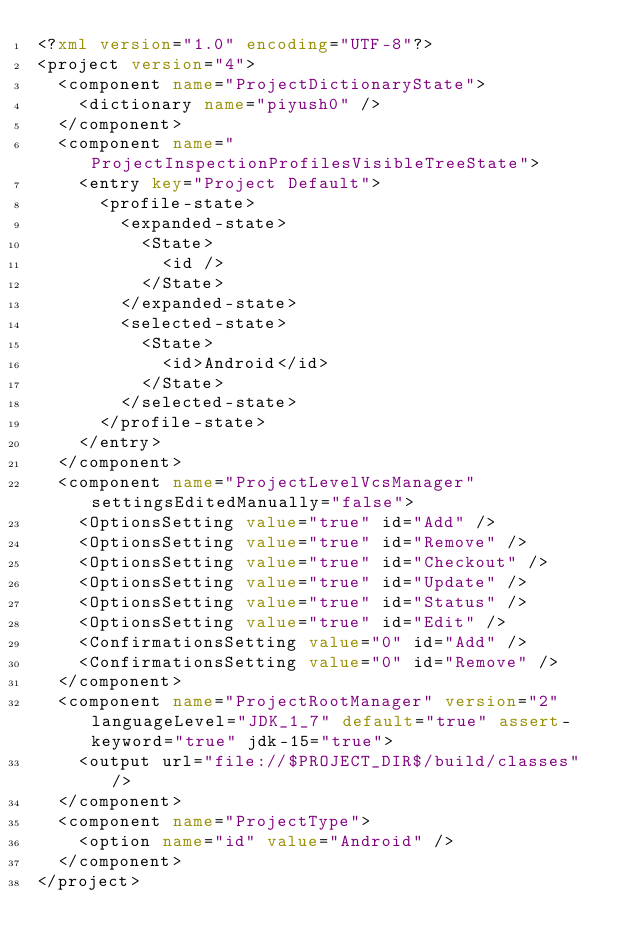<code> <loc_0><loc_0><loc_500><loc_500><_XML_><?xml version="1.0" encoding="UTF-8"?>
<project version="4">
  <component name="ProjectDictionaryState">
    <dictionary name="piyush0" />
  </component>
  <component name="ProjectInspectionProfilesVisibleTreeState">
    <entry key="Project Default">
      <profile-state>
        <expanded-state>
          <State>
            <id />
          </State>
        </expanded-state>
        <selected-state>
          <State>
            <id>Android</id>
          </State>
        </selected-state>
      </profile-state>
    </entry>
  </component>
  <component name="ProjectLevelVcsManager" settingsEditedManually="false">
    <OptionsSetting value="true" id="Add" />
    <OptionsSetting value="true" id="Remove" />
    <OptionsSetting value="true" id="Checkout" />
    <OptionsSetting value="true" id="Update" />
    <OptionsSetting value="true" id="Status" />
    <OptionsSetting value="true" id="Edit" />
    <ConfirmationsSetting value="0" id="Add" />
    <ConfirmationsSetting value="0" id="Remove" />
  </component>
  <component name="ProjectRootManager" version="2" languageLevel="JDK_1_7" default="true" assert-keyword="true" jdk-15="true">
    <output url="file://$PROJECT_DIR$/build/classes" />
  </component>
  <component name="ProjectType">
    <option name="id" value="Android" />
  </component>
</project></code> 